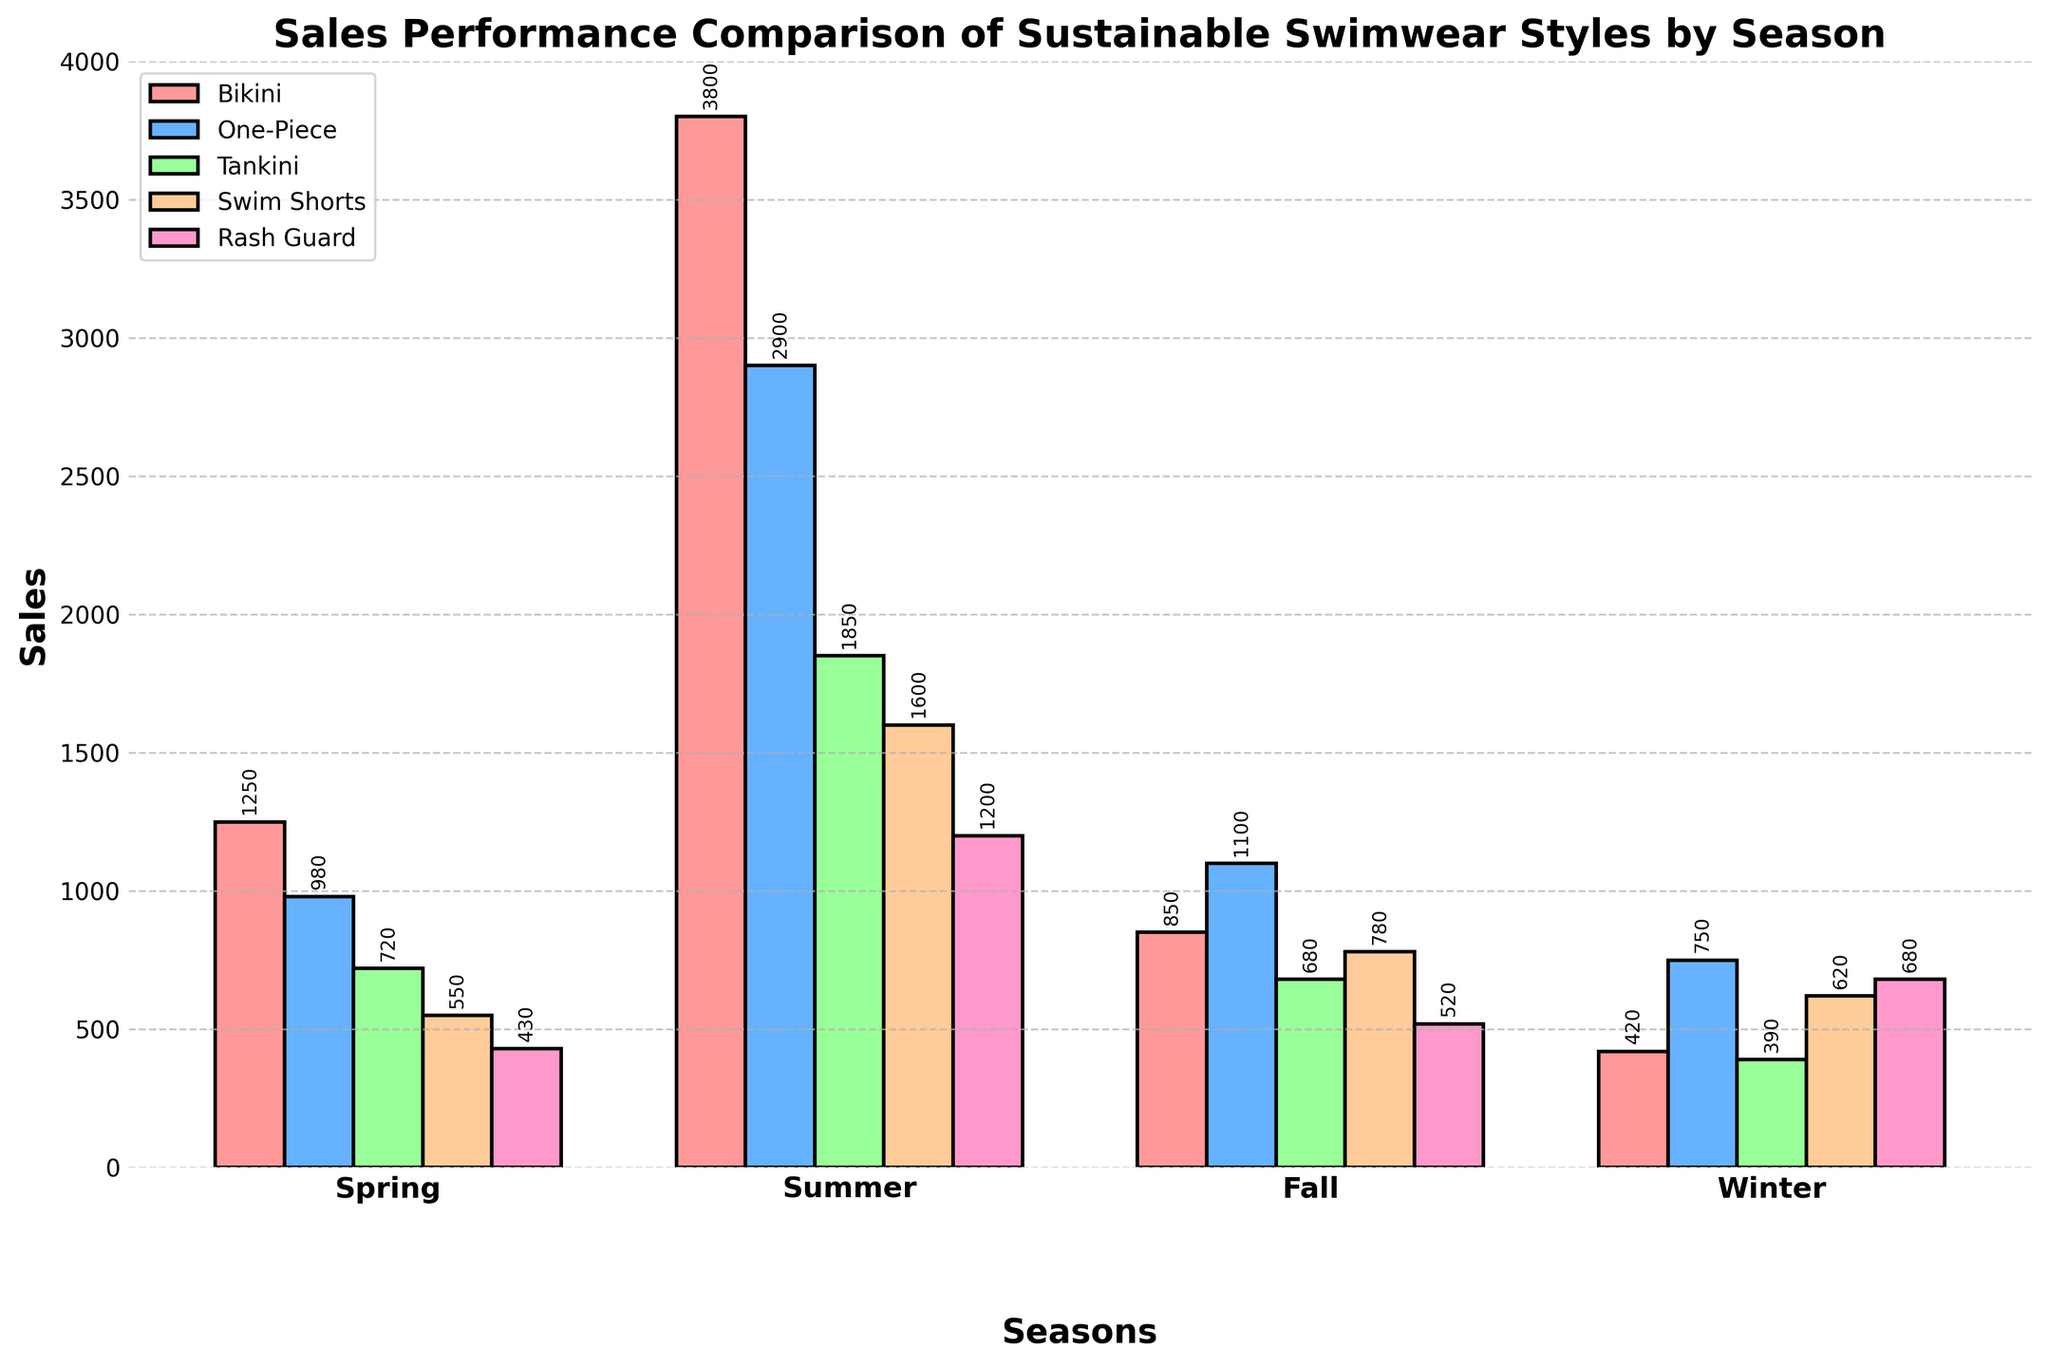Which swimwear style had the highest sales in Summer? The figure shows that the Bikini style has the tallest bar in Summer. By inspecting the bars, the Bikini style had the highest sales at 3800.
Answer: Bikini Among all the seasons, which season had the lowest sales for Rash Guard? The figure indicates that the Rash Guard sales are represented by pink bars. By comparing these bars across all seasons, Winter has the shortest bar for Rash Guard at 680, which is higher than the bar in Spring at 430.
Answer: Spring What is the total sales of One-Piece swimwear across all seasons? The One-Piece sales are represented by light blue bars. Adding the sales for One-Piece from each season: 980 (Spring) + 2900 (Summer) + 1100 (Fall) + 750 (Winter) = 5730.
Answer: 5730 What is the difference in sales between Tankini and Swim Shorts in Fall? The Tankini sales and Swim Shorts sales in Fall are represented by green and orange bars respectively. The Tankini sales are 680 and Swim Shorts sales are 780. The difference is 780 - 680 = 100.
Answer: 100 In which season did the sales of Swim Shorts nearly equal the sales of Rash Guard? By visually comparing the orange and pink bars for Swim Shorts and Rash Guard respectively in each season, Summer has 1600 Swim Shorts sales and 1200 Rash Guard sales, showing a close match.
Answer: Summer What is the highest recorded sales figure for any swimwear style in Winter? The bars for Winter show the sales for each style. The One-Piece has the highest bar with sales of 750.
Answer: 750 Which swimwear style consistently had increasing sales from Spring to Summer and then a decrease by Winter? Checking the progression of each style's bar from Spring to Summer to Fall to Winter, the One-Piece style (light blue bars) shows an upward trend from Spring (980) to Summer (2900) and then decreases through Fall (1100) to Winter (750).
Answer: One-Piece How do Bikini sales in Spring compare to Tankini sales in Summer? The Bikini sales in Spring are represented by the red bar at 1250, and the Tankini sales in Summer by the green bar at 1850. Bikini sales in Spring are less than Tankini sales in Summer.
Answer: Less What is the average sales of Rash Guard across all seasons? Summing up Rash Guard sales: 430 (Spring) + 1200 (Summer) + 520 (Fall) + 680 (Winter) = 2830. There are 4 seasons, so the average is 2830 / 4 = 707.5.
Answer: 707.5 Which season saw the highest overall sales across all swimwear styles? Adding up sales for all styles per season: 
- Spring = 1250 + 980 + 720 + 550 + 430 = 3930
- Summer = 3800 + 2900 + 1850 + 1600 + 1200 = 11350
- Fall = 850 + 1100 + 680 + 780 + 520 = 3930
- Winter = 420 + 750 + 390 + 620 + 680 = 2860.
Summer has the highest overall sales at 11350.
Answer: Summer 